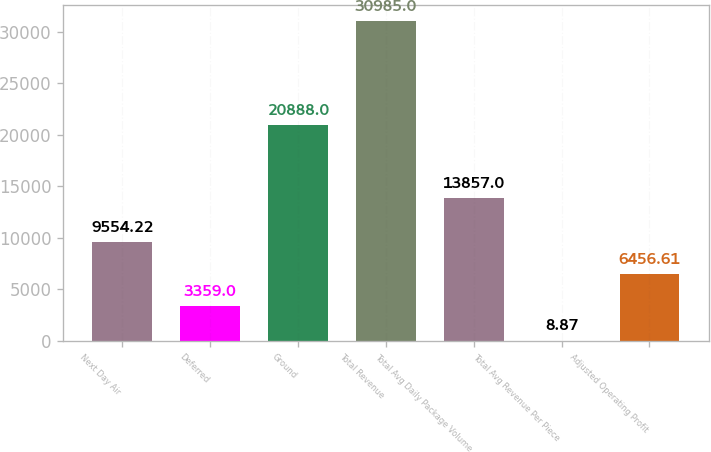<chart> <loc_0><loc_0><loc_500><loc_500><bar_chart><fcel>Next Day Air<fcel>Deferred<fcel>Ground<fcel>Total Revenue<fcel>Total Avg Daily Package Volume<fcel>Total Avg Revenue Per Piece<fcel>Adjusted Operating Profit<nl><fcel>9554.22<fcel>3359<fcel>20888<fcel>30985<fcel>13857<fcel>8.87<fcel>6456.61<nl></chart> 